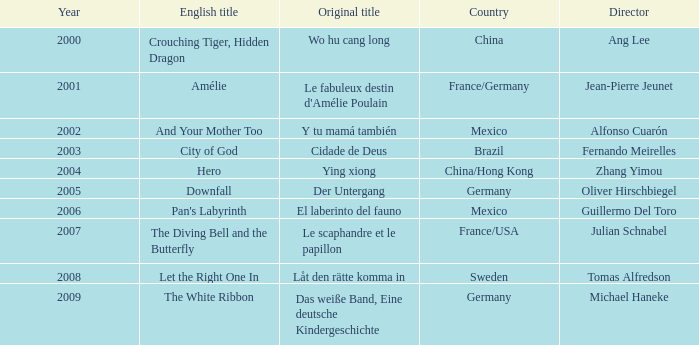Tell me the country for julian schnabel France/USA. 